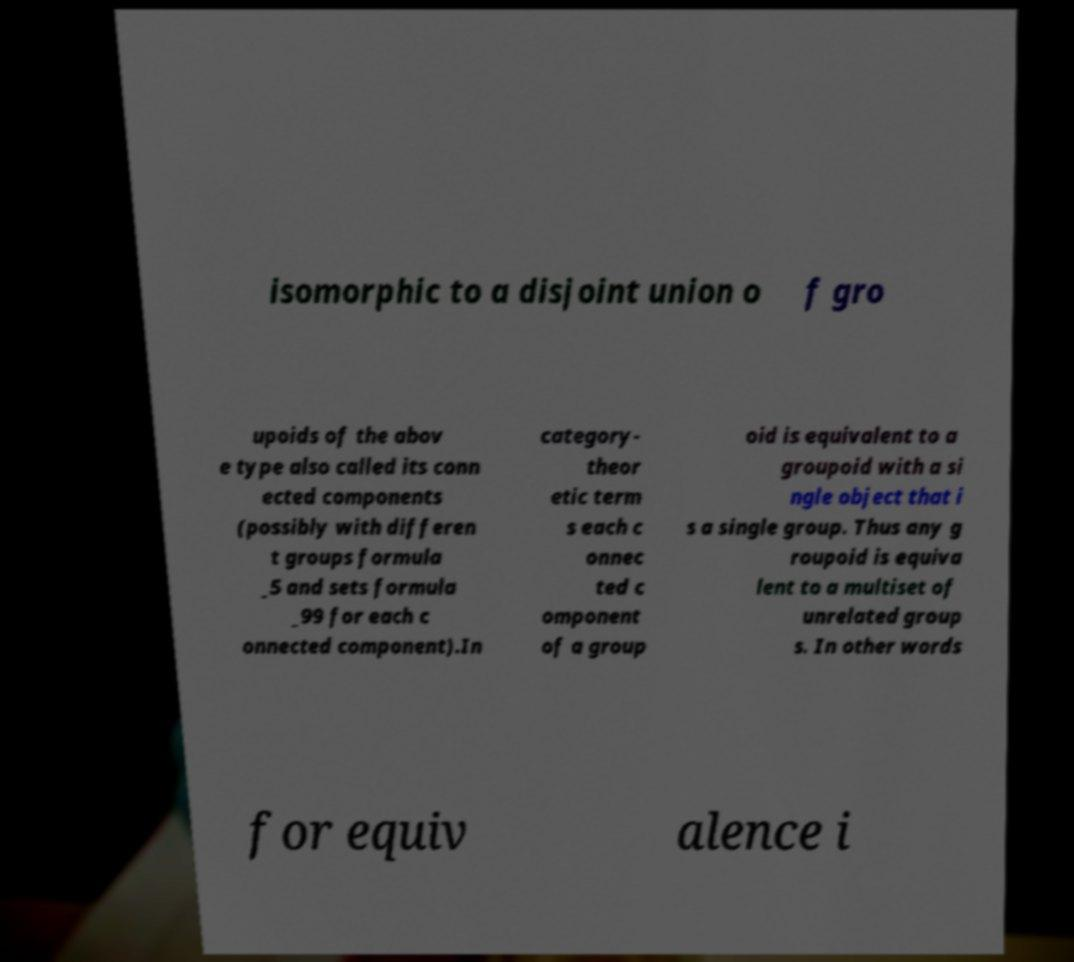I need the written content from this picture converted into text. Can you do that? isomorphic to a disjoint union o f gro upoids of the abov e type also called its conn ected components (possibly with differen t groups formula _5 and sets formula _99 for each c onnected component).In category- theor etic term s each c onnec ted c omponent of a group oid is equivalent to a groupoid with a si ngle object that i s a single group. Thus any g roupoid is equiva lent to a multiset of unrelated group s. In other words for equiv alence i 